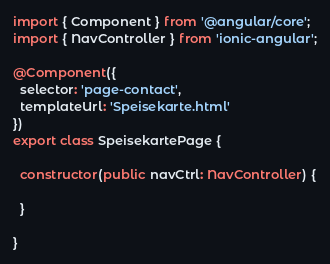<code> <loc_0><loc_0><loc_500><loc_500><_TypeScript_>import { Component } from '@angular/core';
import { NavController } from 'ionic-angular';

@Component({
  selector: 'page-contact',
  templateUrl: 'Speisekarte.html'
})
export class SpeisekartePage {

  constructor(public navCtrl: NavController) {

  }

}
</code> 